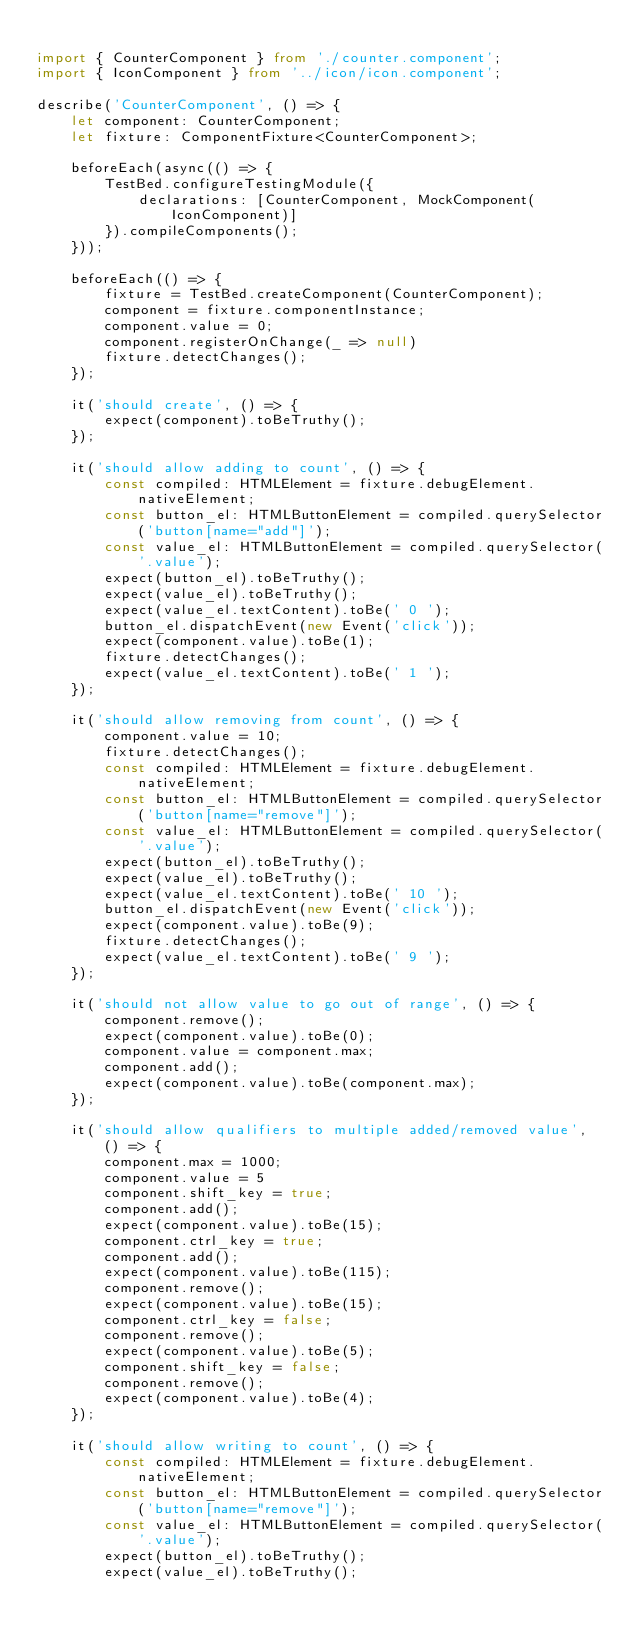Convert code to text. <code><loc_0><loc_0><loc_500><loc_500><_TypeScript_>
import { CounterComponent } from './counter.component';
import { IconComponent } from '../icon/icon.component';

describe('CounterComponent', () => {
    let component: CounterComponent;
    let fixture: ComponentFixture<CounterComponent>;

    beforeEach(async(() => {
        TestBed.configureTestingModule({
            declarations: [CounterComponent, MockComponent(IconComponent)]
        }).compileComponents();
    }));

    beforeEach(() => {
        fixture = TestBed.createComponent(CounterComponent);
        component = fixture.componentInstance;
        component.value = 0;
        component.registerOnChange(_ => null)
        fixture.detectChanges();
    });

    it('should create', () => {
        expect(component).toBeTruthy();
    });

    it('should allow adding to count', () => {
        const compiled: HTMLElement = fixture.debugElement.nativeElement;
        const button_el: HTMLButtonElement = compiled.querySelector('button[name="add"]');
        const value_el: HTMLButtonElement = compiled.querySelector('.value');
        expect(button_el).toBeTruthy();
        expect(value_el).toBeTruthy();
        expect(value_el.textContent).toBe(' 0 ');
        button_el.dispatchEvent(new Event('click'));
        expect(component.value).toBe(1);
        fixture.detectChanges();
        expect(value_el.textContent).toBe(' 1 ');
    });

    it('should allow removing from count', () => {
        component.value = 10;
        fixture.detectChanges();
        const compiled: HTMLElement = fixture.debugElement.nativeElement;
        const button_el: HTMLButtonElement = compiled.querySelector('button[name="remove"]');
        const value_el: HTMLButtonElement = compiled.querySelector('.value');
        expect(button_el).toBeTruthy();
        expect(value_el).toBeTruthy();
        expect(value_el.textContent).toBe(' 10 ');
        button_el.dispatchEvent(new Event('click'));
        expect(component.value).toBe(9);
        fixture.detectChanges();
        expect(value_el.textContent).toBe(' 9 ');
    });

    it('should not allow value to go out of range', () => {
        component.remove();
        expect(component.value).toBe(0);
        component.value = component.max;
        component.add();
        expect(component.value).toBe(component.max);
    });

    it('should allow qualifiers to multiple added/removed value', () => {
        component.max = 1000;
        component.value = 5
        component.shift_key = true;
        component.add();
        expect(component.value).toBe(15);
        component.ctrl_key = true;
        component.add();
        expect(component.value).toBe(115);
        component.remove();
        expect(component.value).toBe(15);
        component.ctrl_key = false;
        component.remove();
        expect(component.value).toBe(5);
        component.shift_key = false;
        component.remove();
        expect(component.value).toBe(4);
    });

    it('should allow writing to count', () => {
        const compiled: HTMLElement = fixture.debugElement.nativeElement;
        const button_el: HTMLButtonElement = compiled.querySelector('button[name="remove"]');
        const value_el: HTMLButtonElement = compiled.querySelector('.value');
        expect(button_el).toBeTruthy();
        expect(value_el).toBeTruthy();</code> 